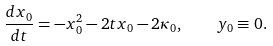<formula> <loc_0><loc_0><loc_500><loc_500>\frac { d x _ { 0 } } { d t } = - x _ { 0 } ^ { 2 } - 2 t x _ { 0 } - 2 \kappa _ { 0 } , \quad y _ { 0 } \equiv 0 .</formula> 